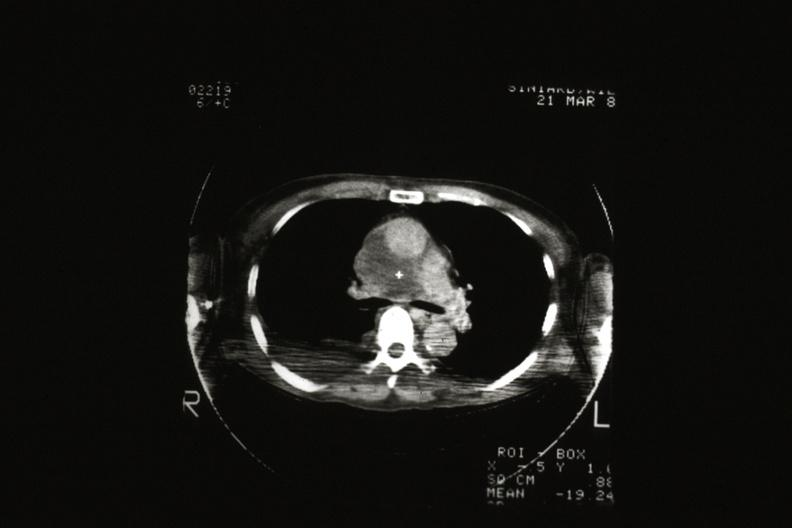what is present?
Answer the question using a single word or phrase. Malignant thymoma 